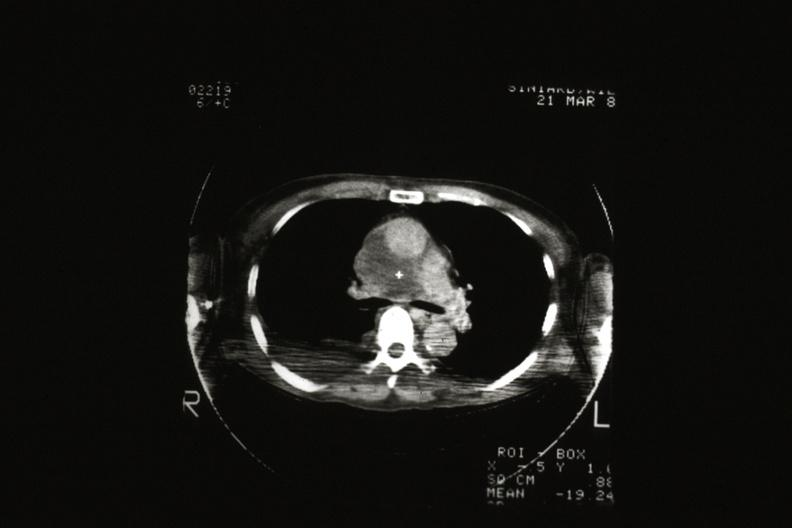what is present?
Answer the question using a single word or phrase. Malignant thymoma 